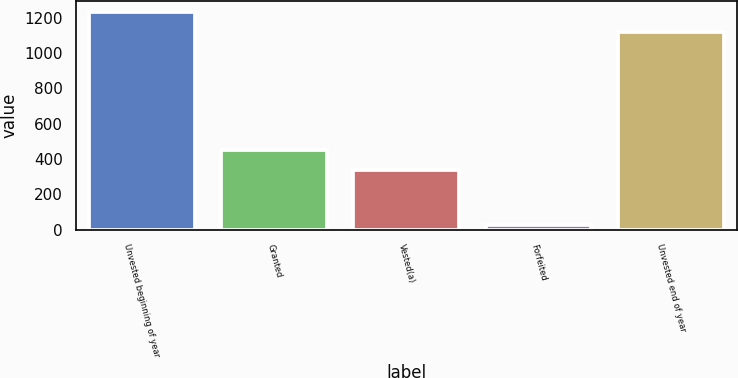<chart> <loc_0><loc_0><loc_500><loc_500><bar_chart><fcel>Unvested beginning of year<fcel>Granted<fcel>Vested(a)<fcel>Forfeited<fcel>Unvested end of year<nl><fcel>1231<fcel>448<fcel>338<fcel>24<fcel>1121<nl></chart> 